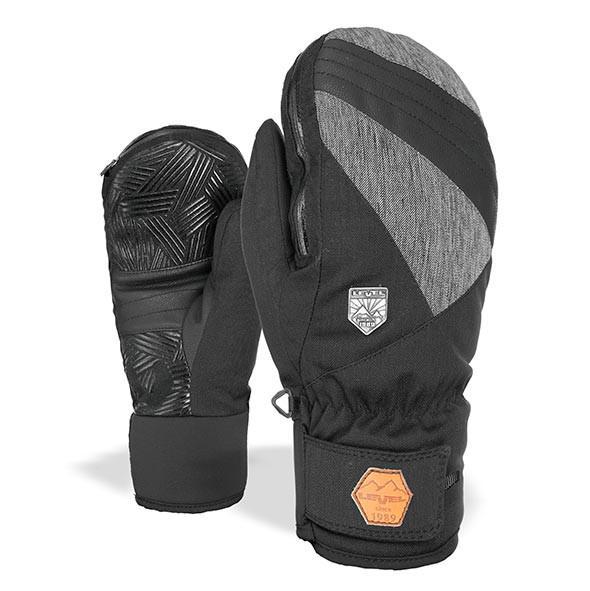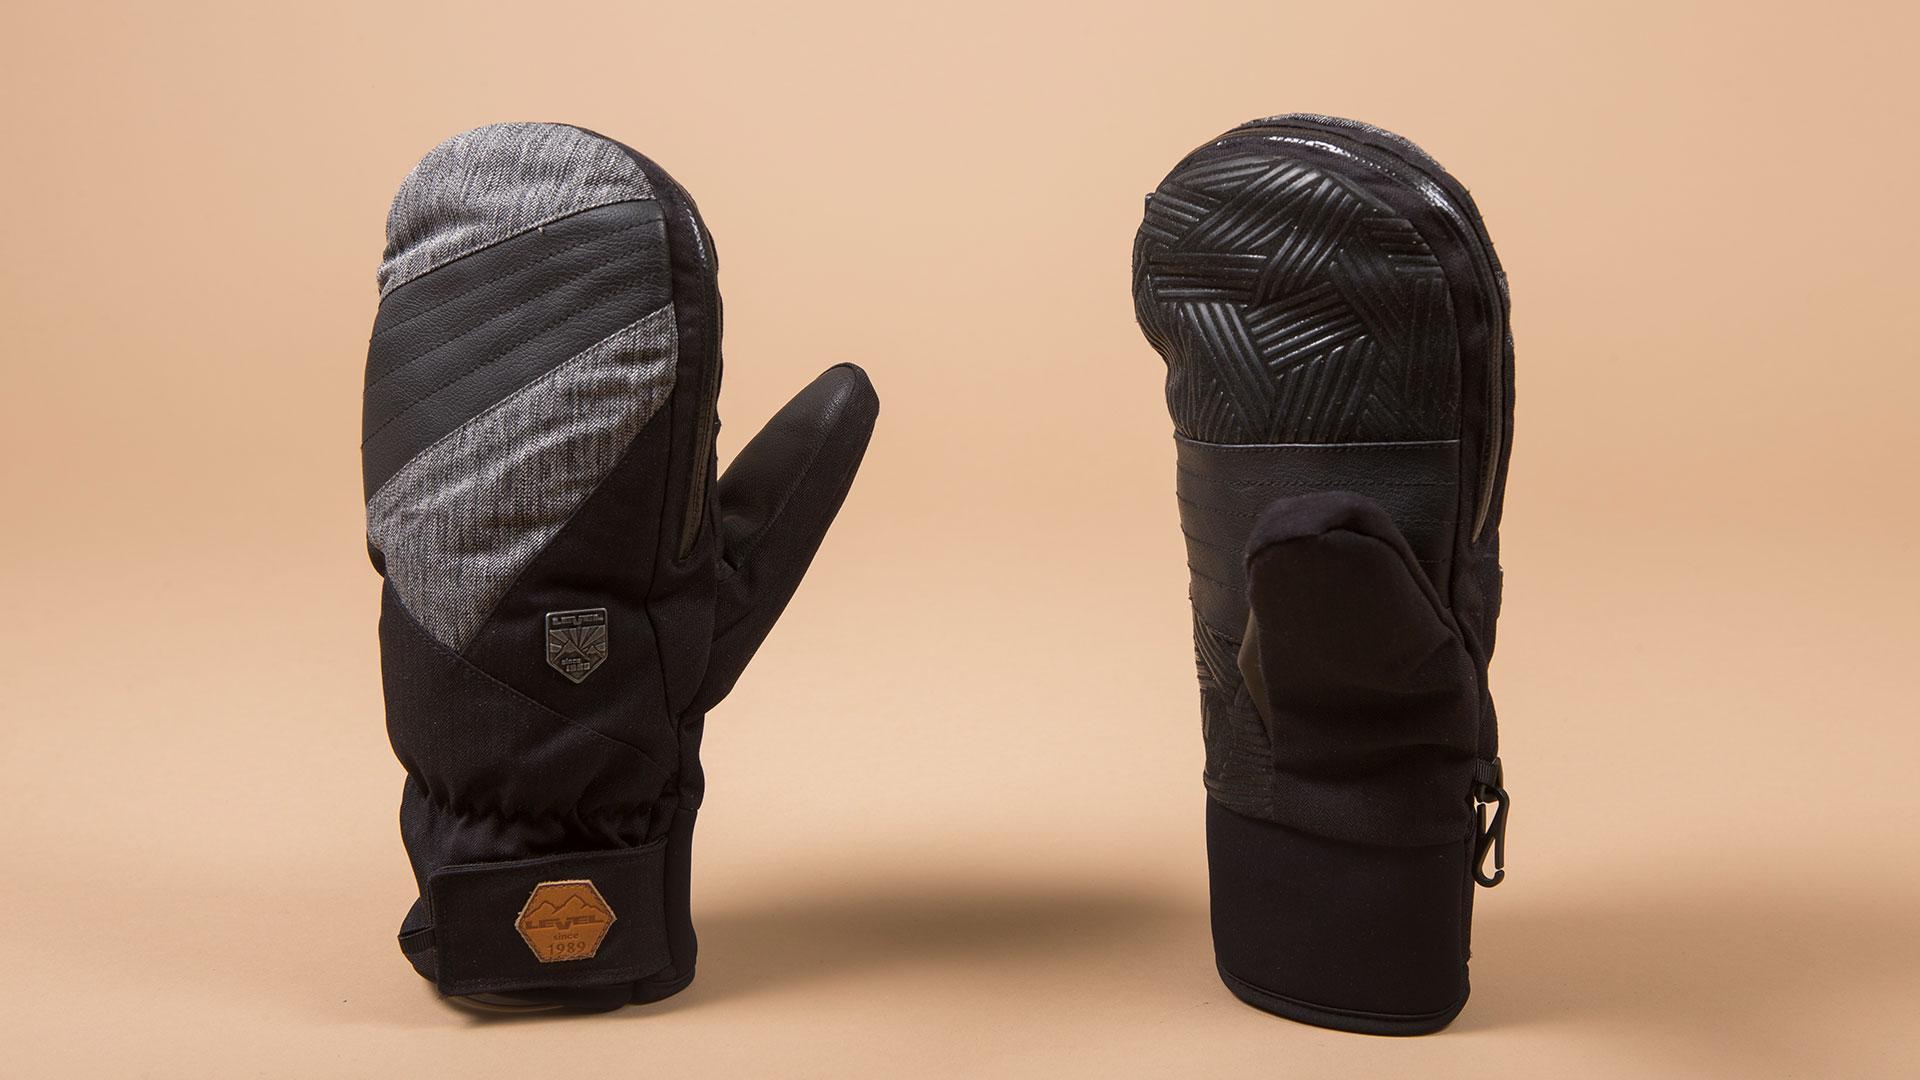The first image is the image on the left, the second image is the image on the right. Assess this claim about the two images: "A glove with individual fingers is visible.". Correct or not? Answer yes or no. No. The first image is the image on the left, the second image is the image on the right. Analyze the images presented: Is the assertion "One image shows a matched pair of mittens, and the other image includes a glove with fingers." valid? Answer yes or no. No. 